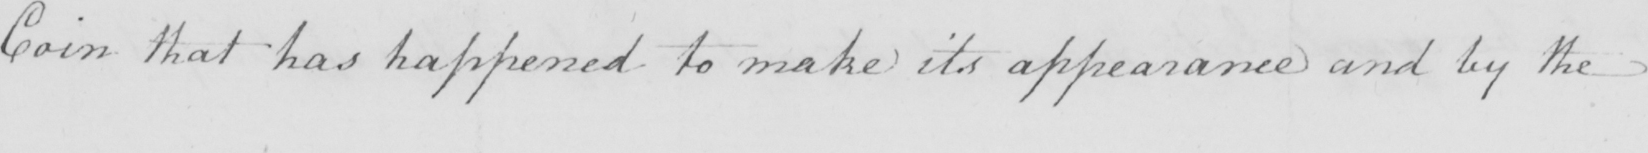Can you tell me what this handwritten text says? Coin that has happened to make its appearance and by the 